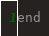Convert code to text. <code><loc_0><loc_0><loc_500><loc_500><_Crystal_>end
</code> 